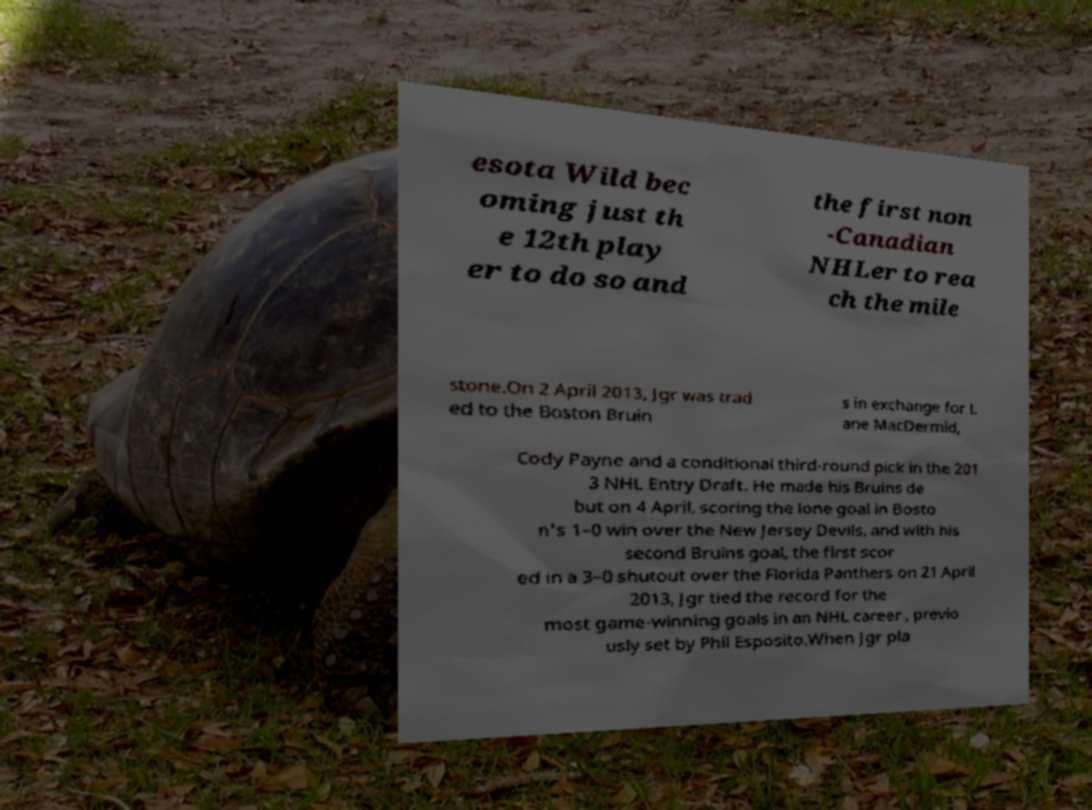For documentation purposes, I need the text within this image transcribed. Could you provide that? esota Wild bec oming just th e 12th play er to do so and the first non -Canadian NHLer to rea ch the mile stone.On 2 April 2013, Jgr was trad ed to the Boston Bruin s in exchange for L ane MacDermid, Cody Payne and a conditional third-round pick in the 201 3 NHL Entry Draft. He made his Bruins de but on 4 April, scoring the lone goal in Bosto n's 1–0 win over the New Jersey Devils, and with his second Bruins goal, the first scor ed in a 3–0 shutout over the Florida Panthers on 21 April 2013, Jgr tied the record for the most game-winning goals in an NHL career , previo usly set by Phil Esposito.When Jgr pla 